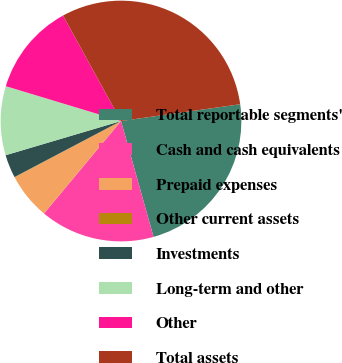Convert chart to OTSL. <chart><loc_0><loc_0><loc_500><loc_500><pie_chart><fcel>Total reportable segments'<fcel>Cash and cash equivalents<fcel>Prepaid expenses<fcel>Other current assets<fcel>Investments<fcel>Long-term and other<fcel>Other<fcel>Total assets<nl><fcel>22.87%<fcel>15.41%<fcel>6.19%<fcel>0.05%<fcel>3.12%<fcel>9.26%<fcel>12.33%<fcel>30.77%<nl></chart> 